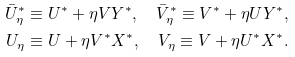Convert formula to latex. <formula><loc_0><loc_0><loc_500><loc_500>\bar { U } _ { \eta } ^ { * } & \equiv U ^ { * } + \eta V Y ^ { * } , \quad \bar { V } _ { \eta } ^ { * } \equiv V ^ { * } + \eta U Y ^ { * } , \\ U _ { \eta } & \equiv U + \eta V ^ { * } X ^ { * } , \quad V _ { \eta } \equiv V + \eta U ^ { * } X ^ { * } .</formula> 